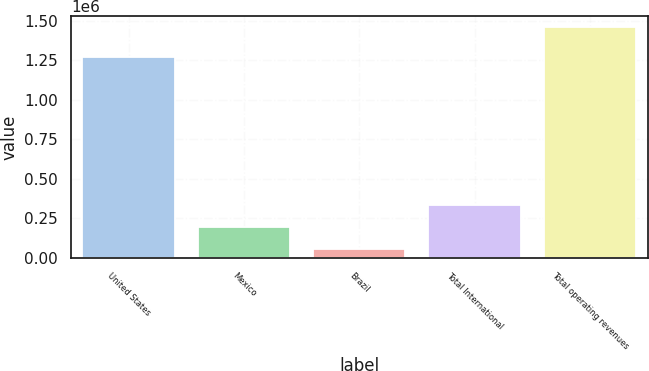<chart> <loc_0><loc_0><loc_500><loc_500><bar_chart><fcel>United States<fcel>Mexico<fcel>Brazil<fcel>Total International<fcel>Total operating revenues<nl><fcel>1.26832e+06<fcel>193790<fcel>53478<fcel>334101<fcel>1.45659e+06<nl></chart> 